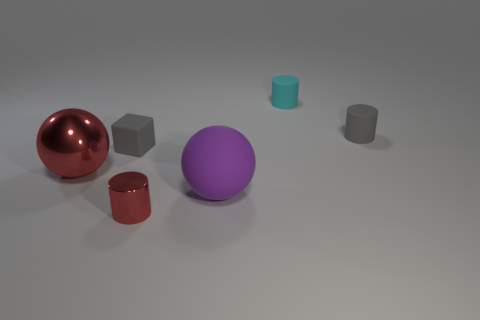There is a rubber cube; is it the same size as the matte ball left of the small cyan cylinder?
Your answer should be very brief. No. How many other metallic things have the same size as the purple object?
Offer a very short reply. 1. What number of small things are either rubber blocks or gray objects?
Ensure brevity in your answer.  2. Are there any tiny green metallic cubes?
Keep it short and to the point. No. Are there more small objects that are on the left side of the cyan matte thing than red cylinders that are in front of the large purple object?
Provide a succinct answer. Yes. What is the color of the rubber thing that is in front of the small gray rubber thing to the left of the small shiny thing?
Your answer should be compact. Purple. Are there any cylinders of the same color as the small block?
Give a very brief answer. Yes. There is a sphere to the right of the metal thing that is in front of the big ball that is behind the purple thing; what is its size?
Provide a succinct answer. Large. What is the shape of the small metal thing?
Provide a succinct answer. Cylinder. There is a object that is the same color as the shiny sphere; what is its size?
Provide a short and direct response. Small. 